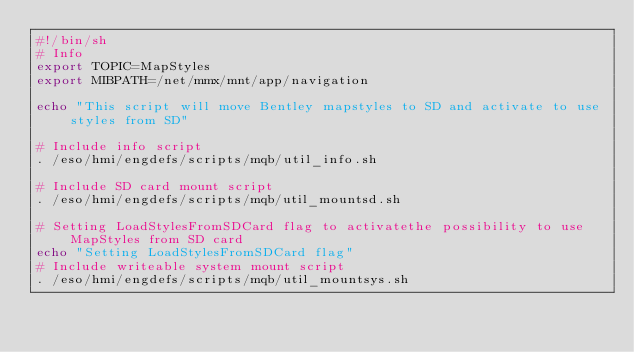Convert code to text. <code><loc_0><loc_0><loc_500><loc_500><_Bash_>#!/bin/sh
# Info
export TOPIC=MapStyles
export MIBPATH=/net/mmx/mnt/app/navigation

echo "This script will move Bentley mapstyles to SD and activate to use styles from SD"

# Include info script
. /eso/hmi/engdefs/scripts/mqb/util_info.sh

# Include SD card mount script
. /eso/hmi/engdefs/scripts/mqb/util_mountsd.sh

# Setting LoadStylesFromSDCard flag to activatethe possibility to use MapStyles from SD card
echo "Setting LoadStylesFromSDCard flag"
# Include writeable system mount script
. /eso/hmi/engdefs/scripts/mqb/util_mountsys.sh</code> 